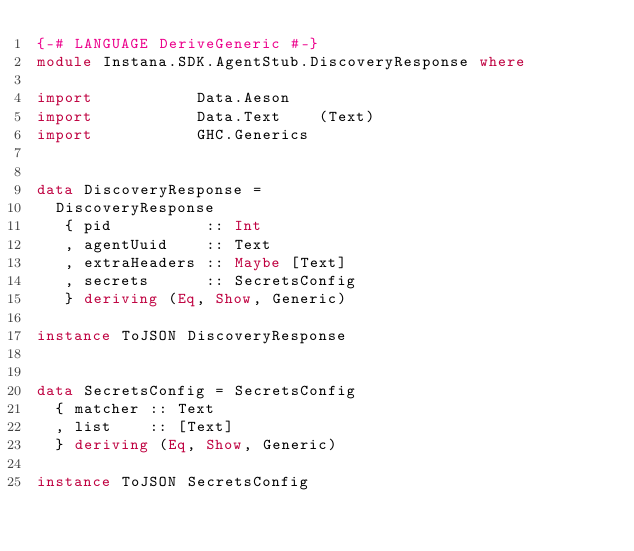<code> <loc_0><loc_0><loc_500><loc_500><_Haskell_>{-# LANGUAGE DeriveGeneric #-}
module Instana.SDK.AgentStub.DiscoveryResponse where

import           Data.Aeson
import           Data.Text    (Text)
import           GHC.Generics


data DiscoveryResponse =
  DiscoveryResponse
   { pid          :: Int
   , agentUuid    :: Text
   , extraHeaders :: Maybe [Text]
   , secrets      :: SecretsConfig
   } deriving (Eq, Show, Generic)

instance ToJSON DiscoveryResponse


data SecretsConfig = SecretsConfig
  { matcher :: Text
  , list    :: [Text]
  } deriving (Eq, Show, Generic)

instance ToJSON SecretsConfig

</code> 